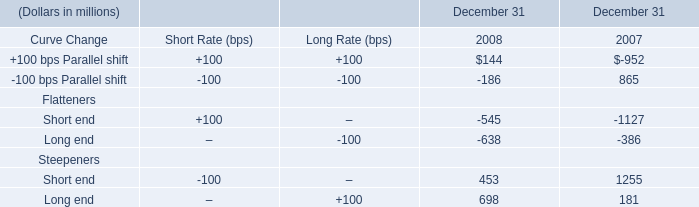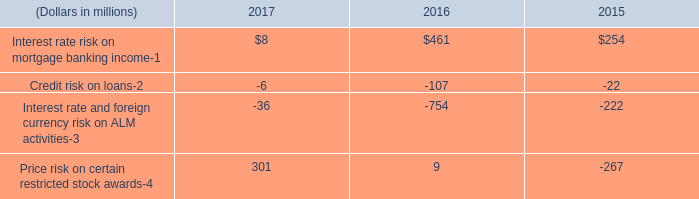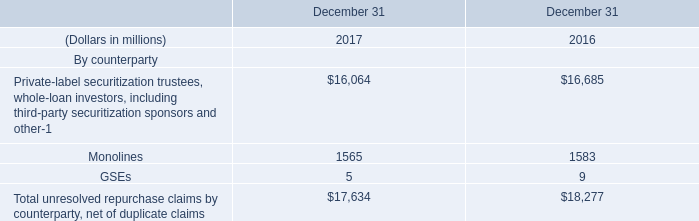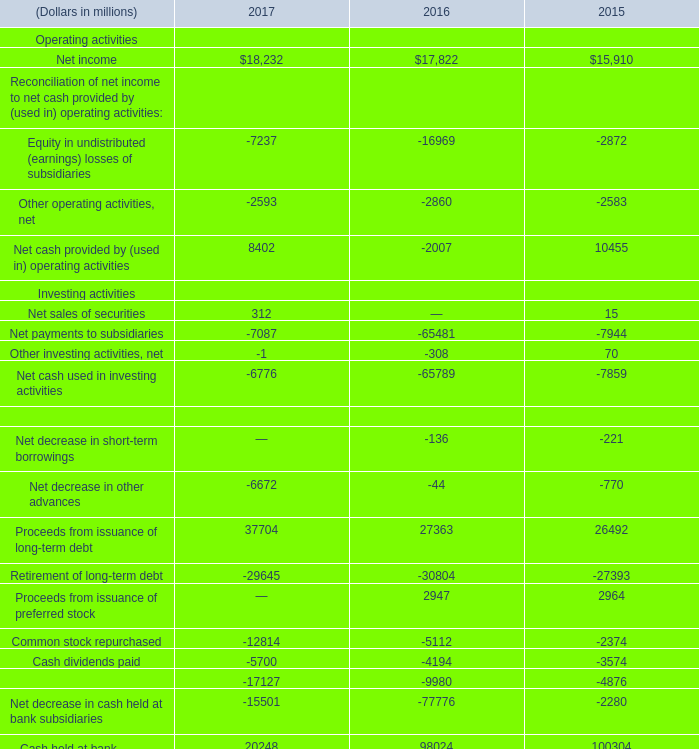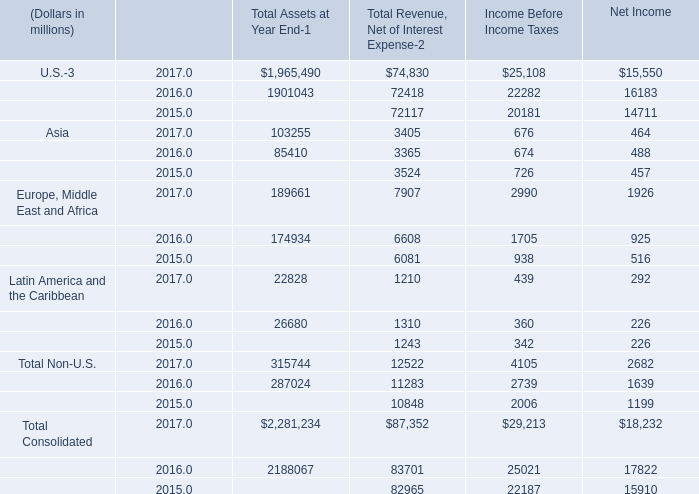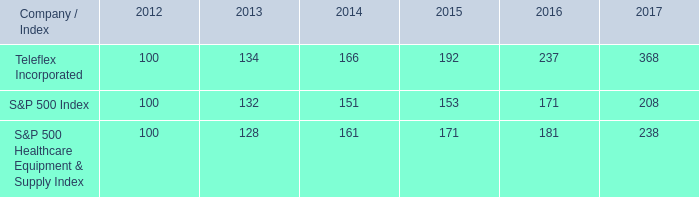what is roi of an investment in teleflex incorporated in 2012 and sold in 2017? 
Computations: ((368 - 100) / 100)
Answer: 2.68. 